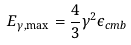Convert formula to latex. <formula><loc_0><loc_0><loc_500><loc_500>E _ { \gamma , \max } = \frac { 4 } { 3 } \gamma ^ { 2 } \epsilon _ { c m b }</formula> 